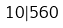<formula> <loc_0><loc_0><loc_500><loc_500>1 0 | 5 6 0</formula> 